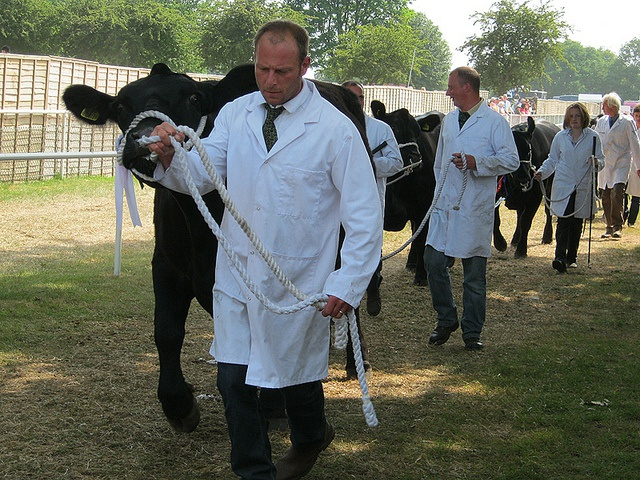Describe the objects in this image and their specific colors. I can see people in darkgreen, darkgray, black, and gray tones, cow in darkgreen, black, gray, and darkgray tones, people in darkgreen, black, and gray tones, people in darkgreen, black, and gray tones, and cow in darkgreen, black, gray, and darkgray tones in this image. 